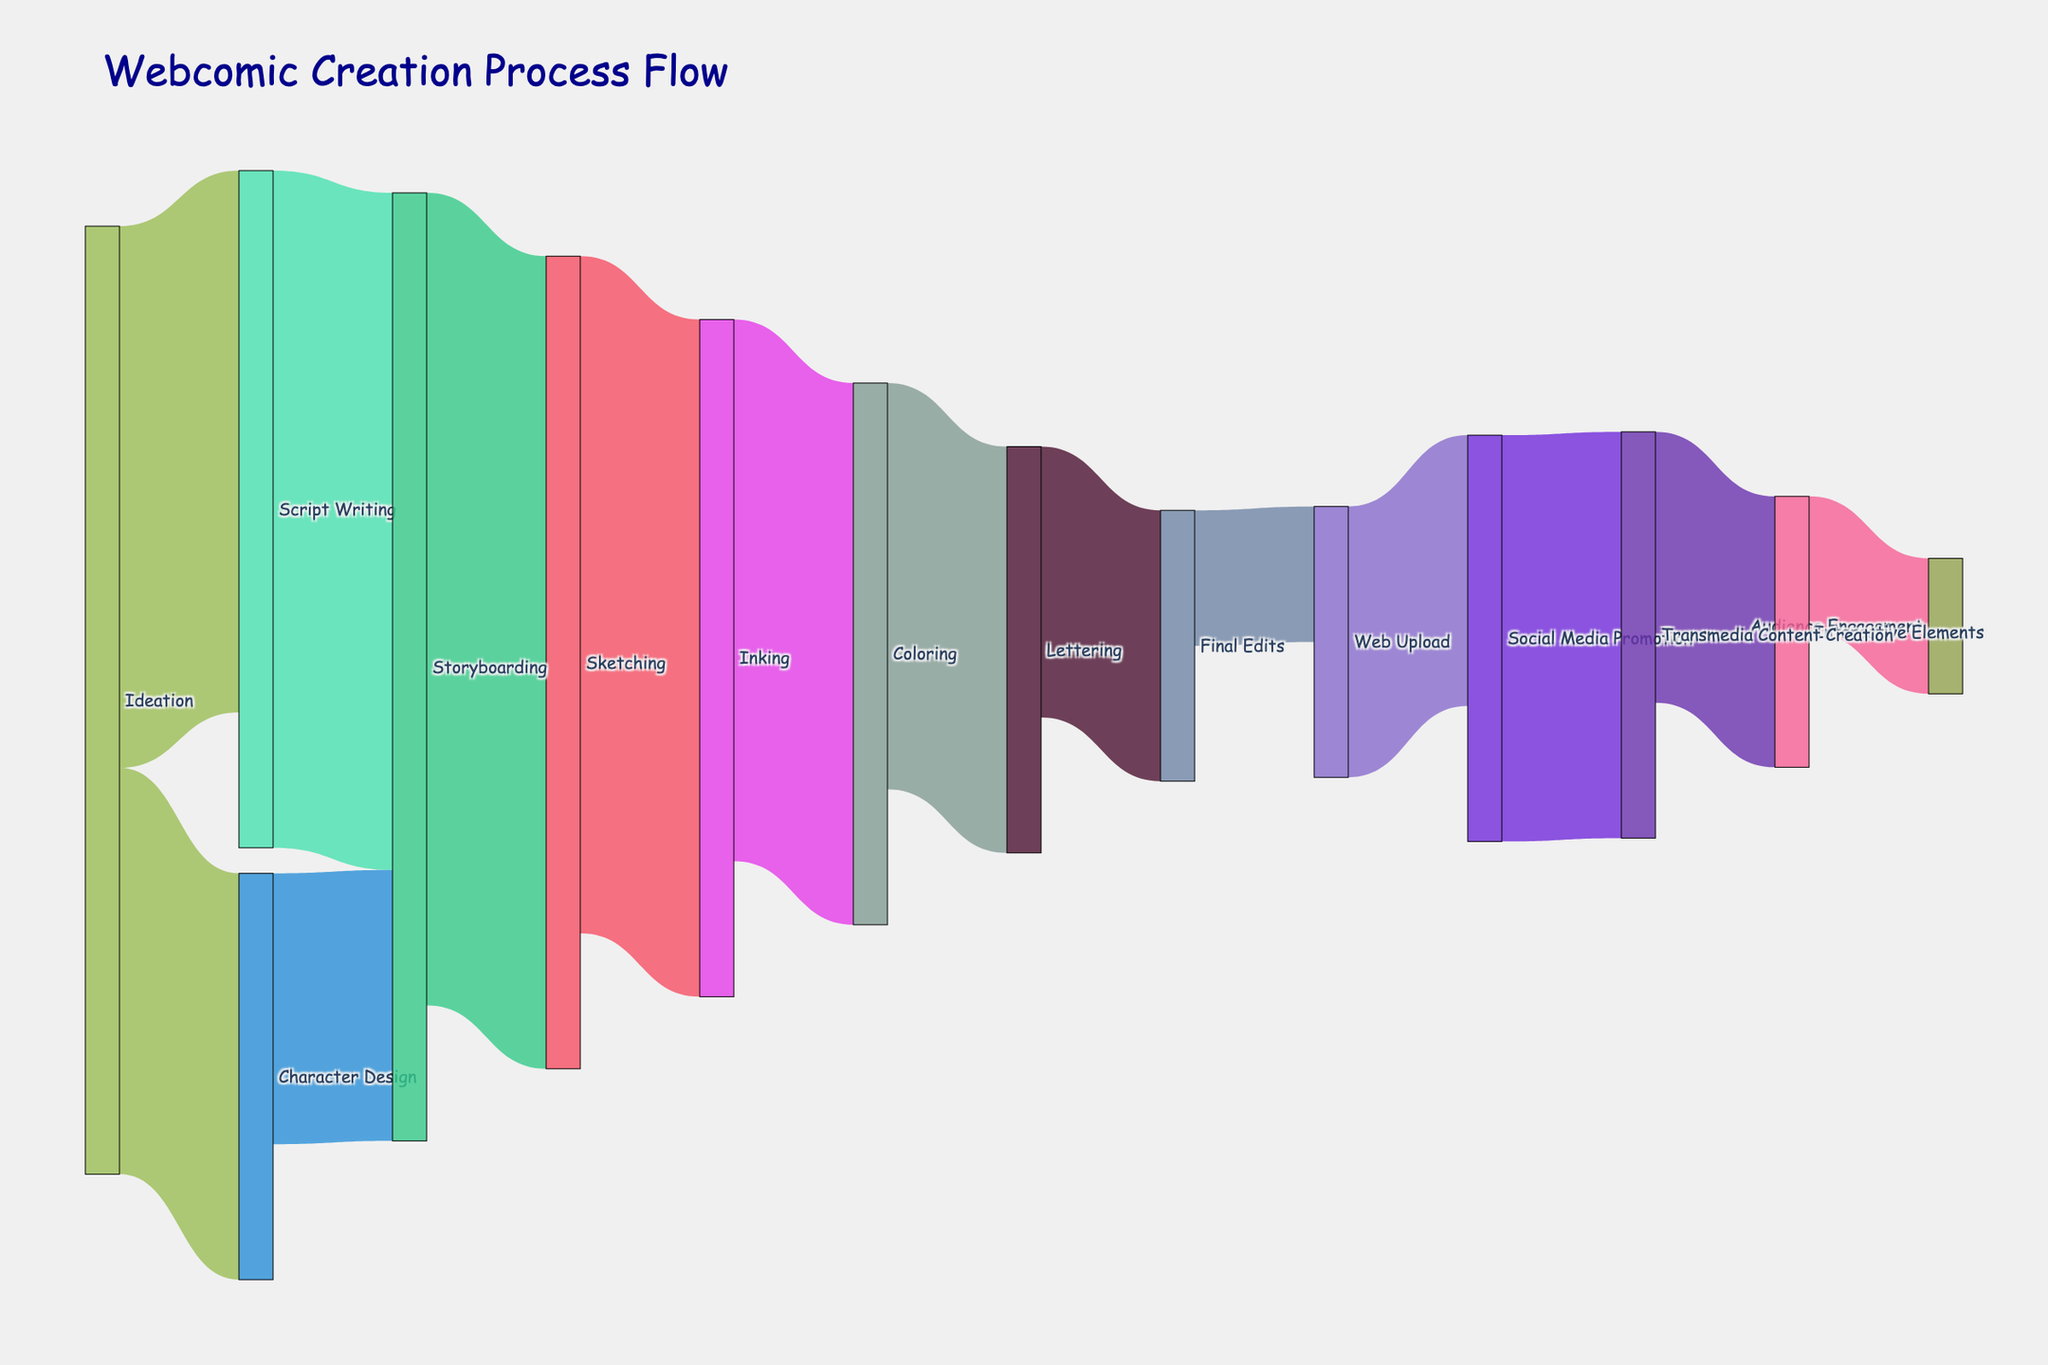What's the title of the Sankey diagram? The title is found at the top of the diagram, indicating the subject of the figure. It helps viewers understand what the visual is about.
Answer: Webcomic Creation Process Flow How many different stages are in the webcomic creation process as visualized in the diagram? Count the unique labels for nodes in the Sankey diagram. Each stage is represented by a unique node.
Answer: 14 What stage follows 'Inking' in the process? Examine the flow from 'Inking' to the next connected stage. Sankey diagrams show flows with links that connect source nodes to target nodes.
Answer: Coloring Which stage has the largest single flow outgoing from it and what is the value? Look for the stage with the widest link coming out of it. The width of the links in a Sankey diagram represents the value of the flow.
Answer: Storyboarding, 30 How much time is spent from 'Character Design' until 'Web Upload'? Sum the values of the links in order starting from 'Character Design' till 'Web Upload': Character Design -> Storyboarding (10), Storyboarding -> Sketching (30), Sketching -> Inking (25), Inking -> Coloring (20), Coloring -> Lettering (15), Lettering -> Final Edits (10), Final Edits -> Web Upload (5).
Answer: 115 What is the total amount of time spent on 'Ideation' in the entire process? Sum the values of all outgoing links from 'Ideation': Ideation -> Script Writing (20), Ideation -> Character Design (15).
Answer: 35 Compare the time spent on Script Writing and Character Design. Which one has more outgoing flow and by how much? Sum the outgoing values for both stages. For Script Writing: Script Writing -> Storyboarding (25). For Character Design: Character Design -> Storyboarding (10). Then compare the totals.
Answer: Script Writing, by 15 Identify the flow with the smallest value and which stages it connects. Examine all links and identify the connection with the smallest value. The smallest width in the Sankey diagram corresponds to the smallest flow value.
Answer: Final Edits to Web Upload, 5 What is the total time spent on 'Transmedia Content Creation' and its subsequent flows? Sum the values of all outgoing links from 'Transmedia Content Creation' and its subsequent connections. Transmedia Content Creation -> Interactive Elements (10), Interactive Elements -> Audience Engagement (5).
Answer: 15 